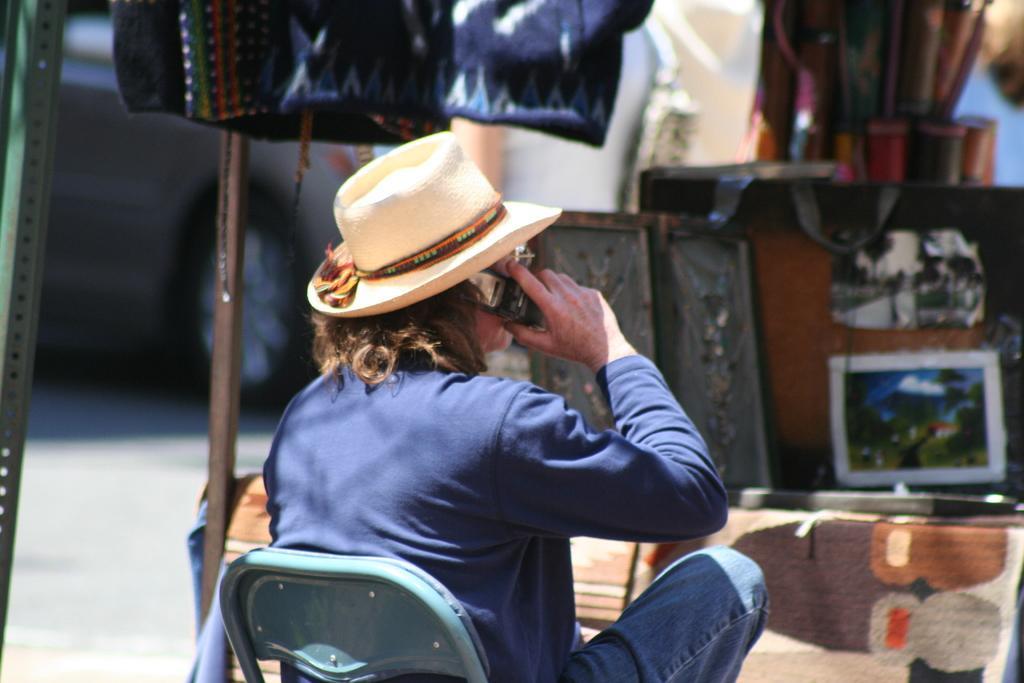In one or two sentences, can you explain what this image depicts? In this image we can see a person wearing hat. And he is holding a phone. He is sitting on a chair. And we can see dresses. In the back there is a stand with screen. In the back it is blurry. 